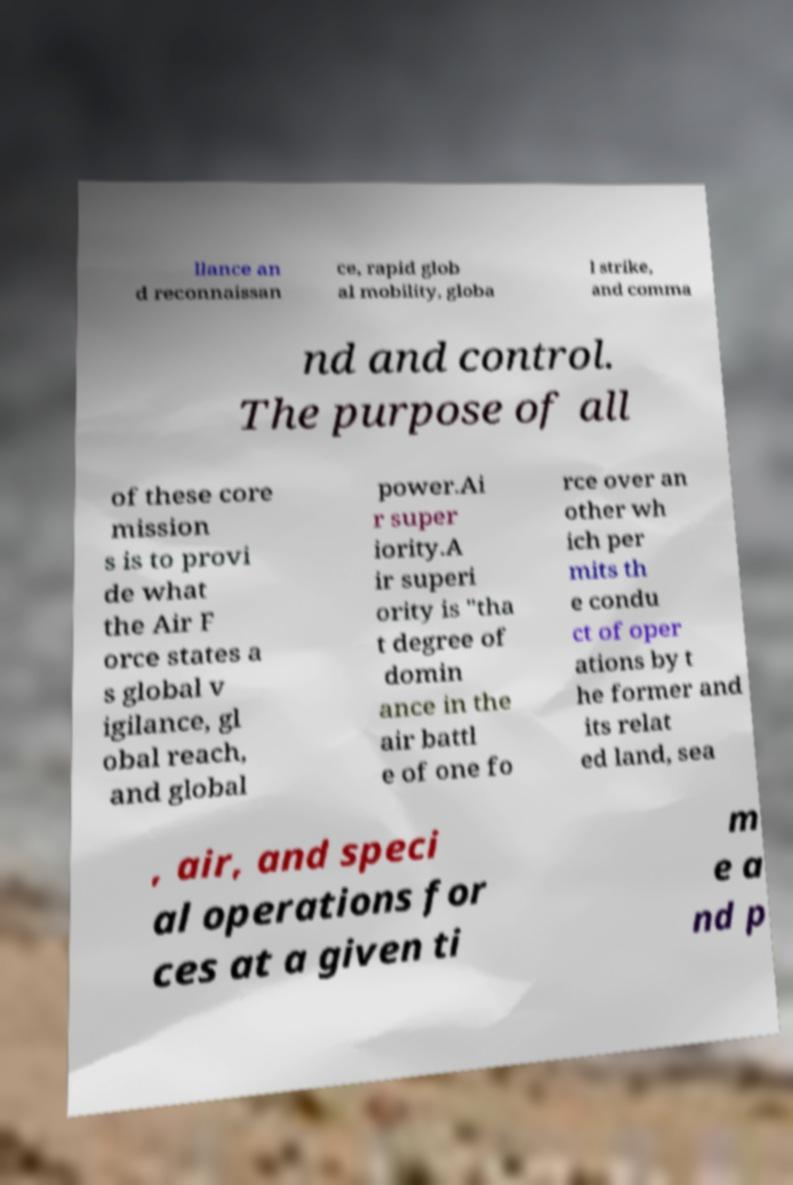There's text embedded in this image that I need extracted. Can you transcribe it verbatim? llance an d reconnaissan ce, rapid glob al mobility, globa l strike, and comma nd and control. The purpose of all of these core mission s is to provi de what the Air F orce states a s global v igilance, gl obal reach, and global power.Ai r super iority.A ir superi ority is "tha t degree of domin ance in the air battl e of one fo rce over an other wh ich per mits th e condu ct of oper ations by t he former and its relat ed land, sea , air, and speci al operations for ces at a given ti m e a nd p 